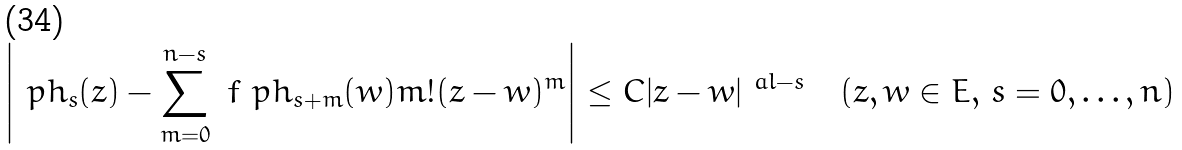<formula> <loc_0><loc_0><loc_500><loc_500>\left | \ p h _ { s } ( z ) - \sum _ { m = 0 } ^ { n - s } \ f { \ p h _ { s + m } ( w ) } { m ! } ( z - w ) ^ { m } \right | \leq C | z - w | ^ { \ a l - s } \quad ( z , w \in E , \, s = 0 , \dots , n )</formula> 